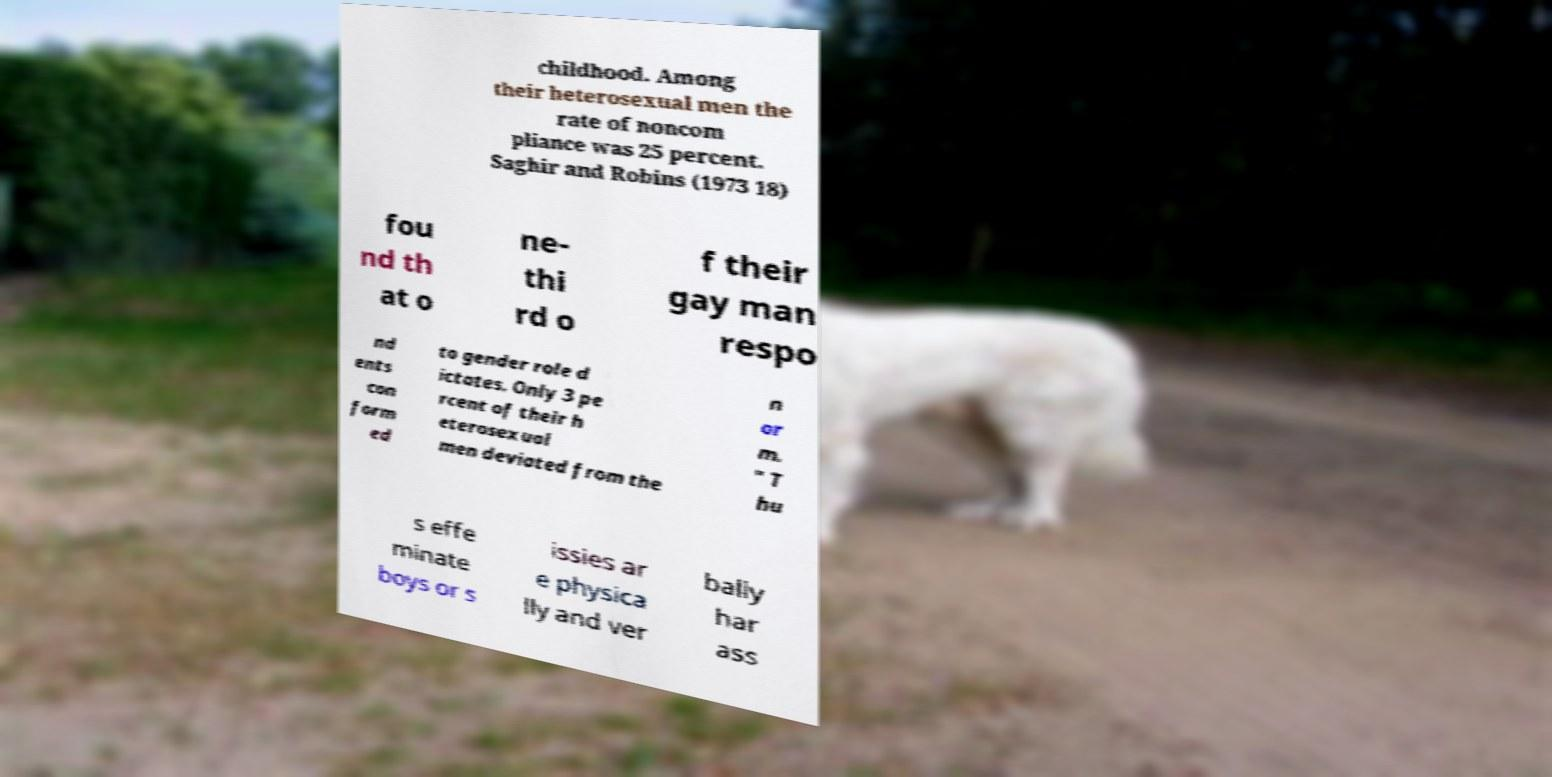For documentation purposes, I need the text within this image transcribed. Could you provide that? childhood. Among their heterosexual men the rate of noncom pliance was 25 percent. Saghir and Robins (1973 18) fou nd th at o ne- thi rd o f their gay man respo nd ents con form ed to gender role d ictates. Only 3 pe rcent of their h eterosexual men deviated from the n or m. " T hu s effe minate boys or s issies ar e physica lly and ver bally har ass 